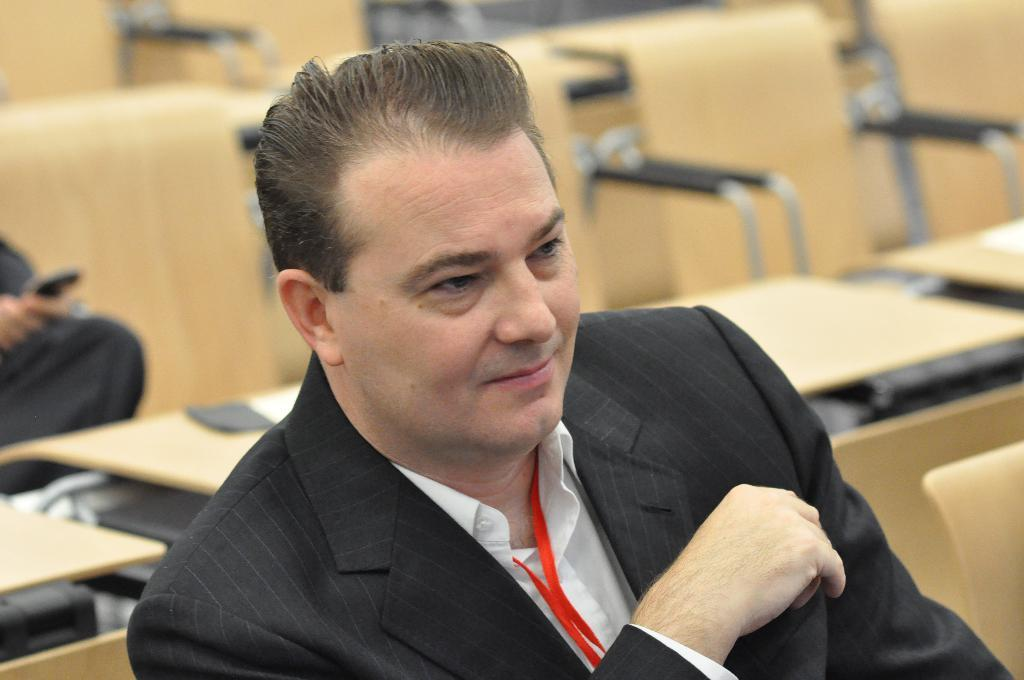Who is present in the image? There is a man in the image. What can be seen in the background of the image? There are tables and chairs in the background of the image. Is there is another person in the image, where are they located? There is another person on the left side of the image. What type of cough does the manager have in the image? There is no mention of a manager or cough in the image; it only features a man and another person. What type of trousers is the man wearing in the image? The provided facts do not mention the type of trousers the man is wearing in the image. 